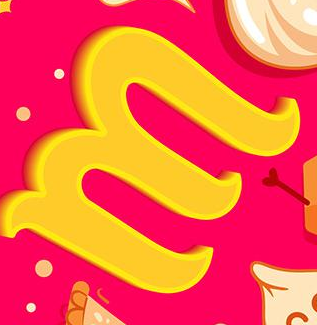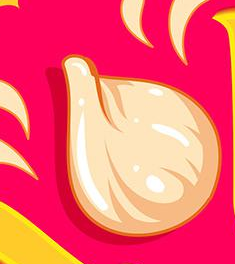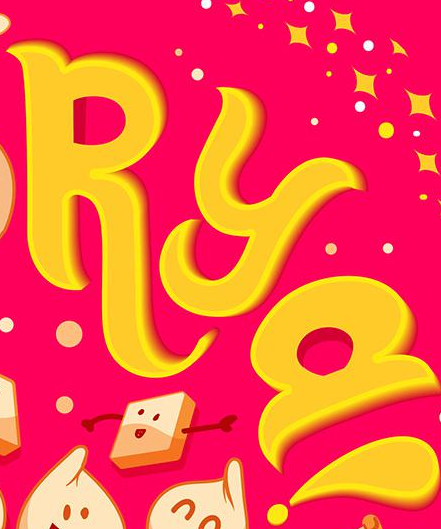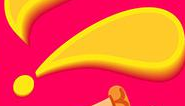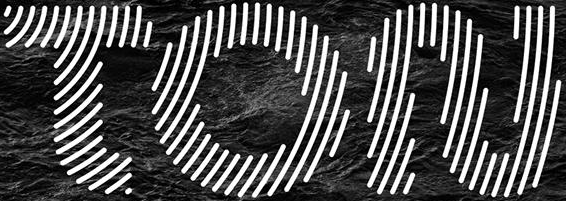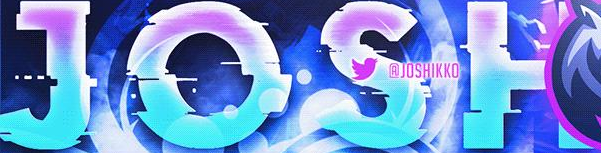What text appears in these images from left to right, separated by a semicolon? M; #; RYa; !; TON; JOSH 